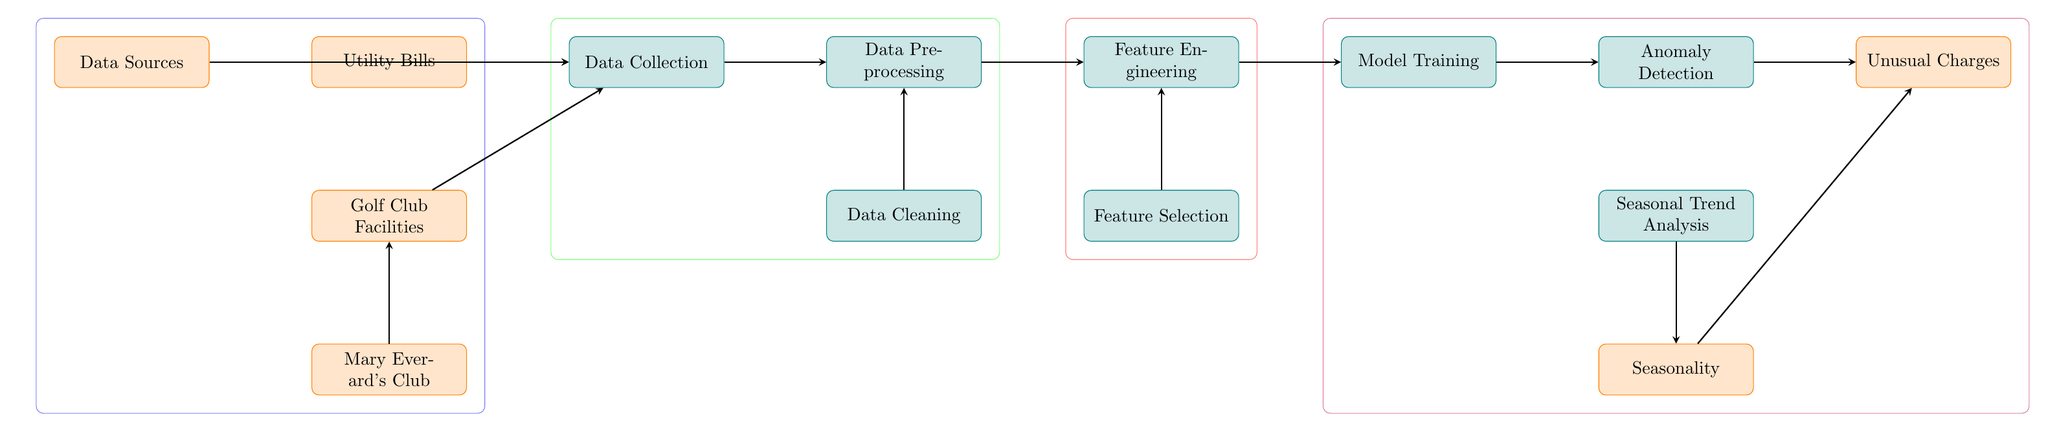How many data sources are listed in the diagram? The diagram indicates there are four data sources: Data Sources, Utility Bills, Golf Club Facilities, and Mary Everard's Club.
Answer: 4 What process comes after data collection? According to the flow of the diagram, the process that follows data collection is data preprocessing.
Answer: Data Preprocessing Which two processes lead to seasonal trend analysis? The diagram shows that both anomaly detection and seasonality lead to seasonal trend analysis, indicating their sequential relationship before this analysis.
Answer: Anomaly Detection, Seasonality What is identified from the anomaly detection process? The outcome resulting from the anomaly detection process, as shown in the diagram, is unusual charges.
Answer: Unusual Charges Which node does Mary Everard's Club connect to? In the diagram, Mary Everard's Club is connected to Golf Club Facilities, indicating the relation through which data is processed.
Answer: Golf Club Facilities What color is used for the process nodes in the diagram? The process nodes in the diagram are all colored teal, as visually represented in the nodes.
Answer: Teal What process precedes feature selection? According to the diagram, feature engineering precedes the feature selection process, indicating the order of operations leading to selection.
Answer: Feature Engineering How many processes are in the last group of nodes? The last group of nodes includes three processes: model training, anomaly detection, and seasonal trend analysis, which suggests their interconnection in this phase.
Answer: 3 Which two elements are grouped in purple? The purple group contains model training and anomaly detection along with seasonal trend analysis, seasonality, and unusual charges, pointing towards advanced analysis and prediction.
Answer: Model Training, Anomaly Detection 